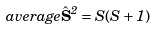Convert formula to latex. <formula><loc_0><loc_0><loc_500><loc_500>\ a v e r a g e { { \hat { \mathbf S } } ^ { 2 } } = S ( S + 1 )</formula> 